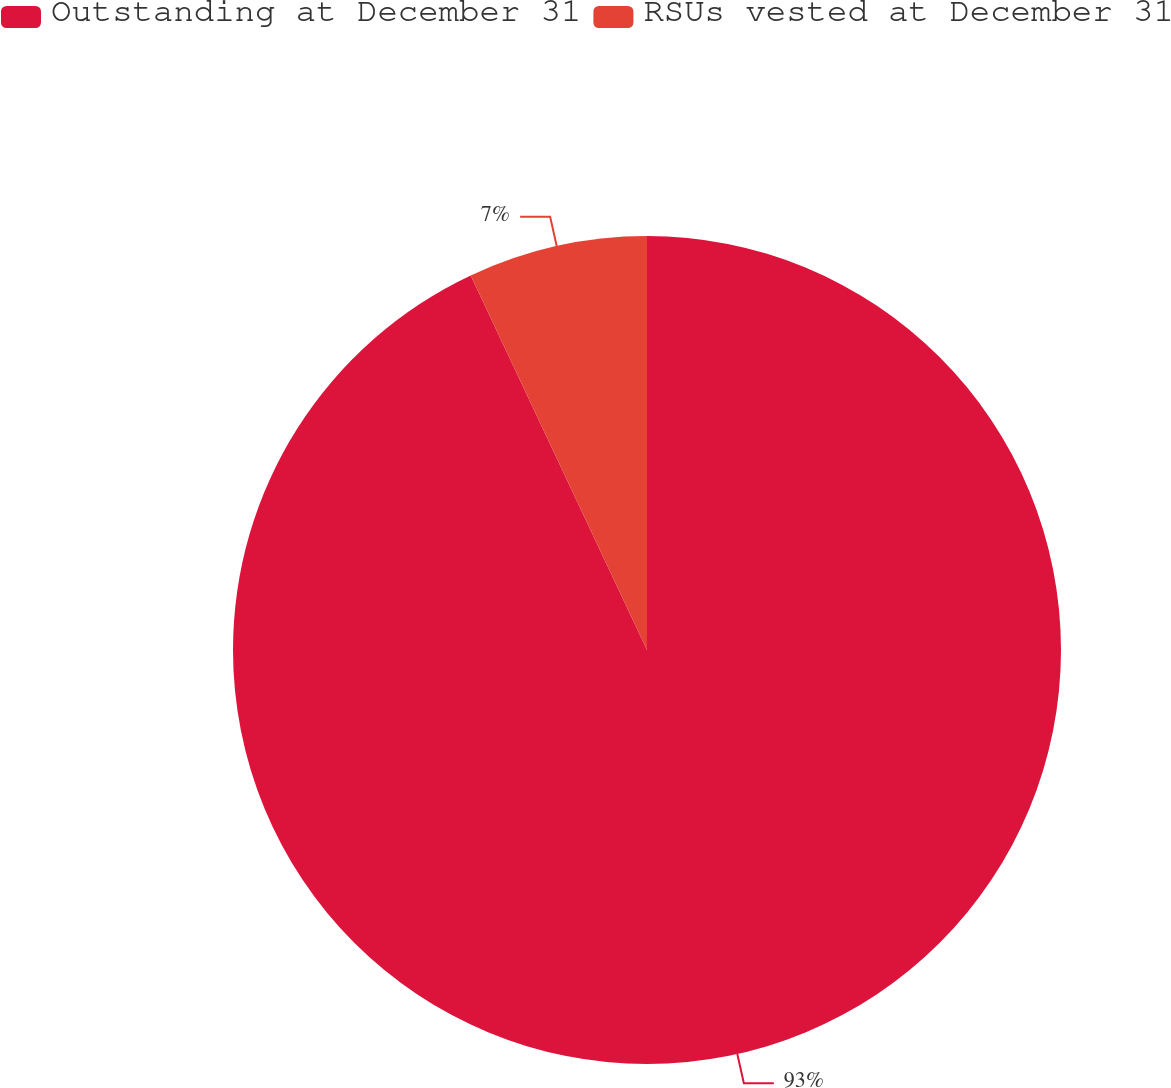Convert chart to OTSL. <chart><loc_0><loc_0><loc_500><loc_500><pie_chart><fcel>Outstanding at December 31<fcel>RSUs vested at December 31<nl><fcel>93.0%<fcel>7.0%<nl></chart> 